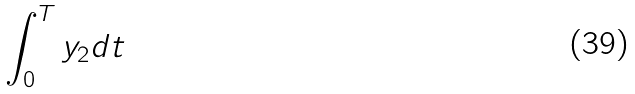Convert formula to latex. <formula><loc_0><loc_0><loc_500><loc_500>\int _ { 0 } ^ { T } y _ { 2 } d t</formula> 